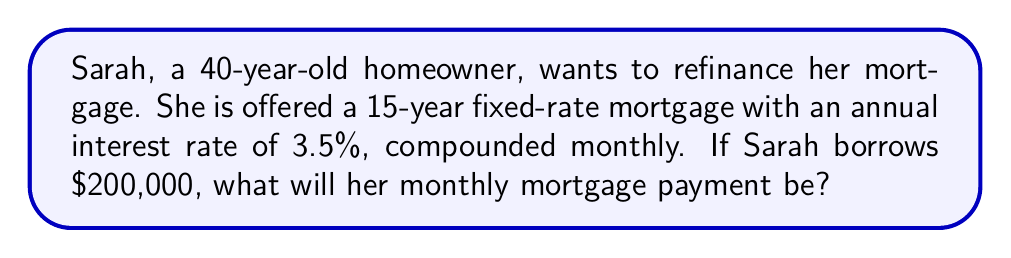Show me your answer to this math problem. To calculate the monthly mortgage payment, we'll use the fixed-rate mortgage formula:

$$P = L \frac{r(1+r)^n}{(1+r)^n - 1}$$

Where:
$P$ = monthly payment
$L$ = loan amount
$r$ = monthly interest rate
$n$ = total number of monthly payments

Step 1: Calculate the monthly interest rate
Annual rate = 3.5% = 0.035
Monthly rate = $r = \frac{0.035}{12} = 0.002916667$

Step 2: Calculate the total number of monthly payments
15 years = 180 months, so $n = 180$

Step 3: Plug the values into the formula
$P = 200000 \frac{0.002916667(1+0.002916667)^{180}}{(1+0.002916667)^{180} - 1}$

Step 4: Use a calculator to solve this equation
$P = 200000 \frac{0.002916667 \times 1.683045407}{0.683045407}$
$P = 200000 \times 0.007149498$
$P = 1,429.90$

Therefore, Sarah's monthly mortgage payment will be $1,429.90.
Answer: $1,429.90 